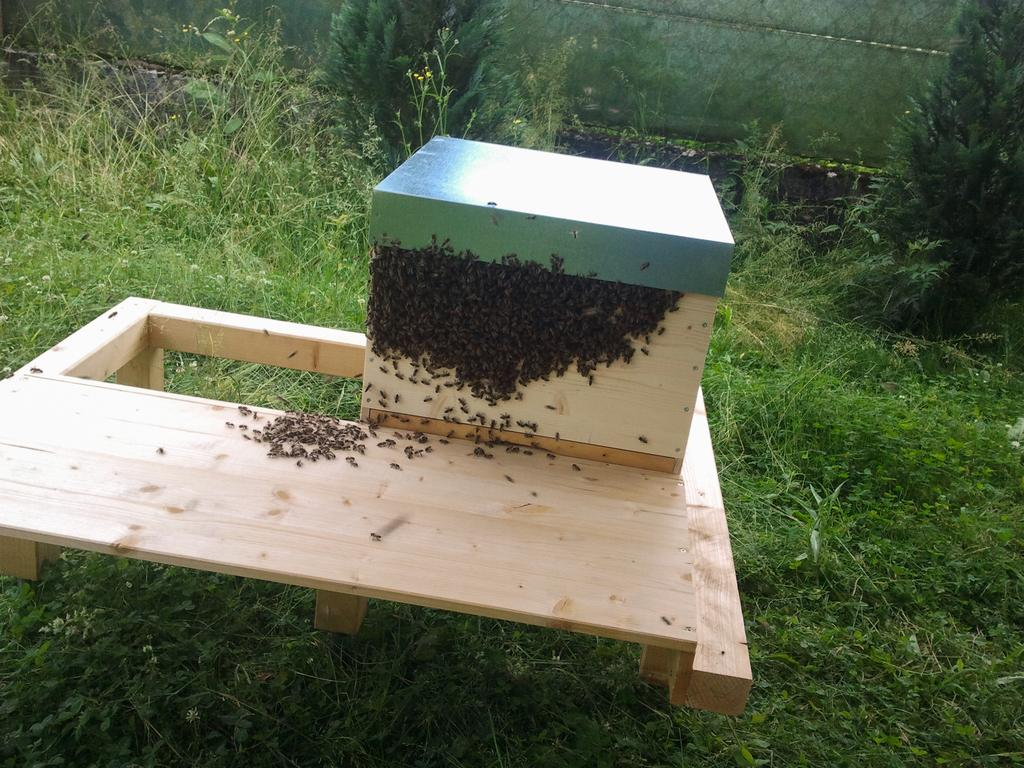What type of ground is visible in the image? There is grass ground in the image. What is placed on the grass ground? There is a wooden object on the grass ground. What can be seen on the wooden object? There are honeybees on the wooden object. What is visible in the background of the image? There are two trees in the background of the image. Can you tell me what color the girl's dress is in the image? There is no girl present in the image. What type of needle is being used by the aunt in the image? There is no aunt or needle present in the image. 